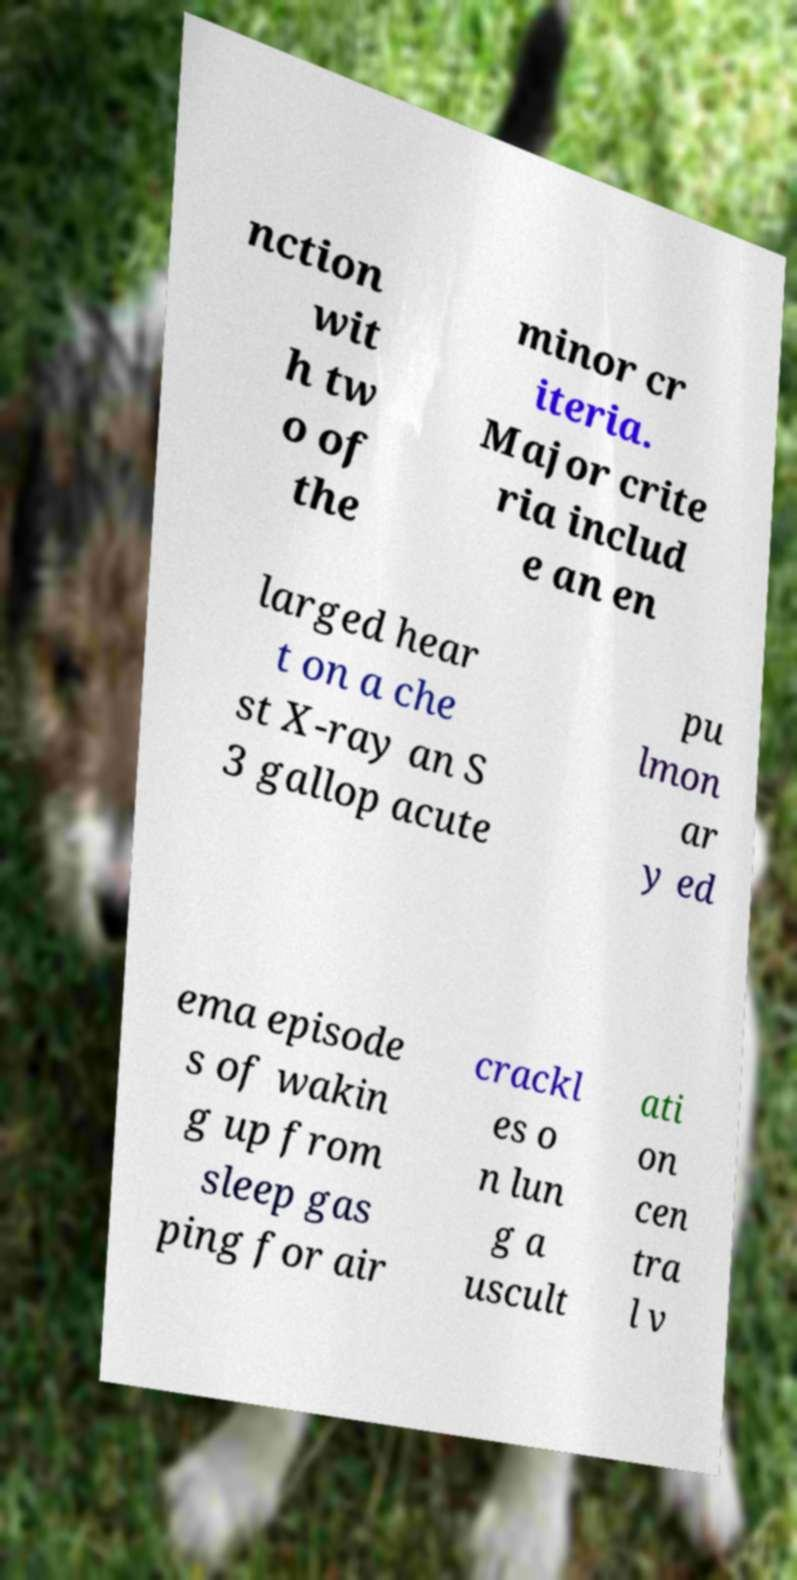For documentation purposes, I need the text within this image transcribed. Could you provide that? nction wit h tw o of the minor cr iteria. Major crite ria includ e an en larged hear t on a che st X-ray an S 3 gallop acute pu lmon ar y ed ema episode s of wakin g up from sleep gas ping for air crackl es o n lun g a uscult ati on cen tra l v 